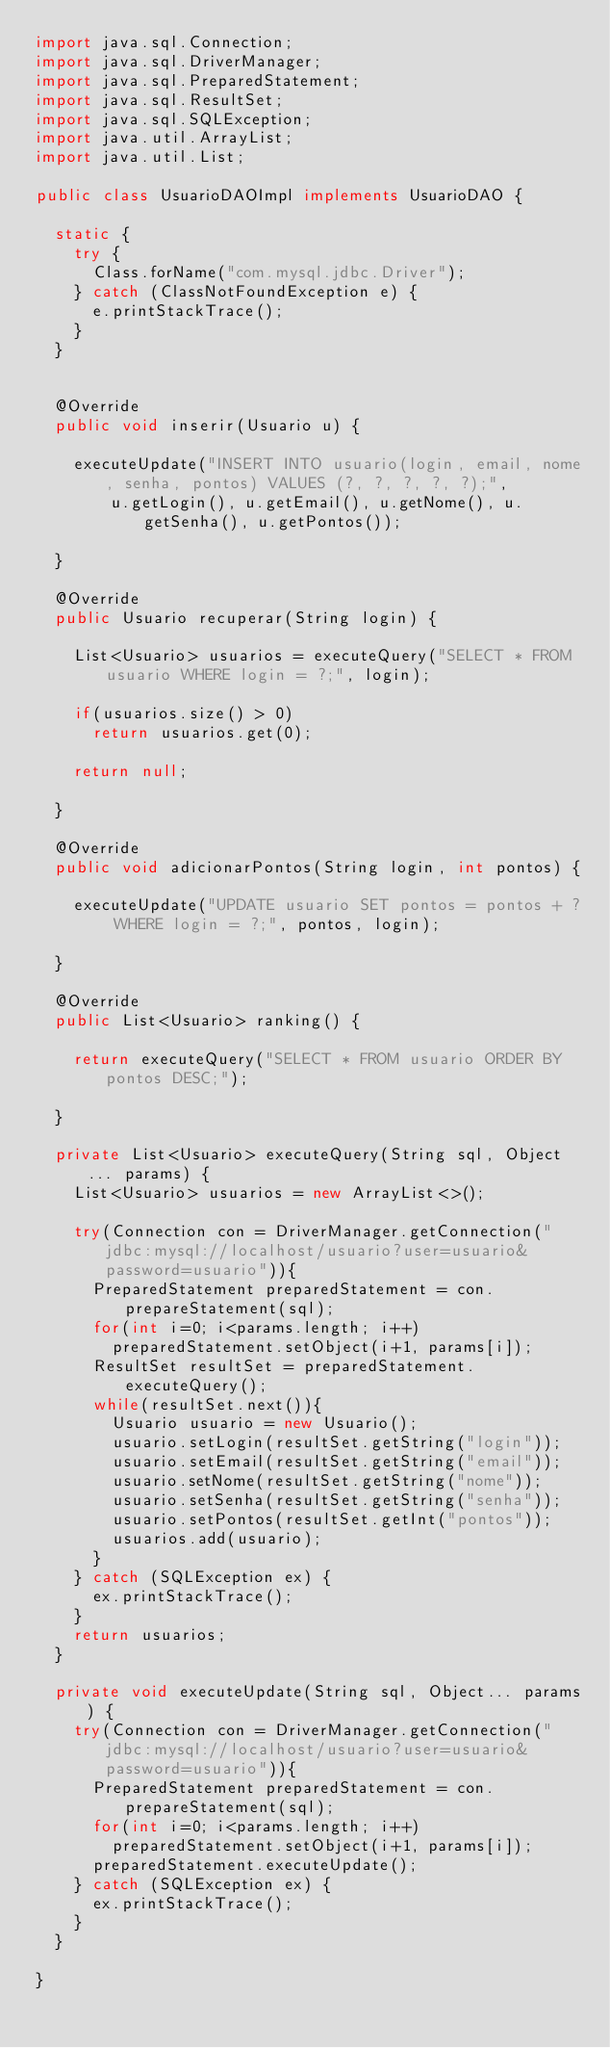Convert code to text. <code><loc_0><loc_0><loc_500><loc_500><_Java_>import java.sql.Connection;
import java.sql.DriverManager;
import java.sql.PreparedStatement;
import java.sql.ResultSet;
import java.sql.SQLException;
import java.util.ArrayList;
import java.util.List;

public class UsuarioDAOImpl implements UsuarioDAO {
	
	static {
		try {
			Class.forName("com.mysql.jdbc.Driver");
		} catch (ClassNotFoundException e) {
			e.printStackTrace();
		}
	}
	

	@Override
	public void inserir(Usuario u) {

		executeUpdate("INSERT INTO usuario(login, email, nome, senha, pontos) VALUES (?, ?, ?, ?, ?);", 
				u.getLogin(), u.getEmail(), u.getNome(), u.getSenha(), u.getPontos());

	}

	@Override
	public Usuario recuperar(String login) {
		
		List<Usuario> usuarios = executeQuery("SELECT * FROM usuario WHERE login = ?;", login);
		
		if(usuarios.size() > 0)
			return usuarios.get(0);

		return null;

	}

	@Override
	public void adicionarPontos(String login, int pontos) {

		executeUpdate("UPDATE usuario SET pontos = pontos + ? WHERE login = ?;", pontos, login);

	}

	@Override
	public List<Usuario> ranking() {
		
		return executeQuery("SELECT * FROM usuario ORDER BY pontos DESC;");

	}

	private List<Usuario> executeQuery(String sql, Object... params) {
		List<Usuario> usuarios = new ArrayList<>();
		
		try(Connection con = DriverManager.getConnection("jdbc:mysql://localhost/usuario?user=usuario&password=usuario")){
			PreparedStatement preparedStatement = con.prepareStatement(sql);
			for(int i=0; i<params.length; i++)
				preparedStatement.setObject(i+1, params[i]);
			ResultSet resultSet = preparedStatement.executeQuery();
			while(resultSet.next()){
				Usuario usuario = new Usuario();
				usuario.setLogin(resultSet.getString("login"));
				usuario.setEmail(resultSet.getString("email"));
				usuario.setNome(resultSet.getString("nome"));
				usuario.setSenha(resultSet.getString("senha"));
				usuario.setPontos(resultSet.getInt("pontos"));
				usuarios.add(usuario);
			}
		} catch (SQLException ex) {
			ex.printStackTrace();
		}
		return usuarios;
	}

	private void executeUpdate(String sql, Object... params) {
		try(Connection con = DriverManager.getConnection("jdbc:mysql://localhost/usuario?user=usuario&password=usuario")){
			PreparedStatement preparedStatement = con.prepareStatement(sql);
			for(int i=0; i<params.length; i++)
				preparedStatement.setObject(i+1, params[i]);
			preparedStatement.executeUpdate();
		} catch (SQLException ex) {
			ex.printStackTrace();
		}
	}

}
</code> 